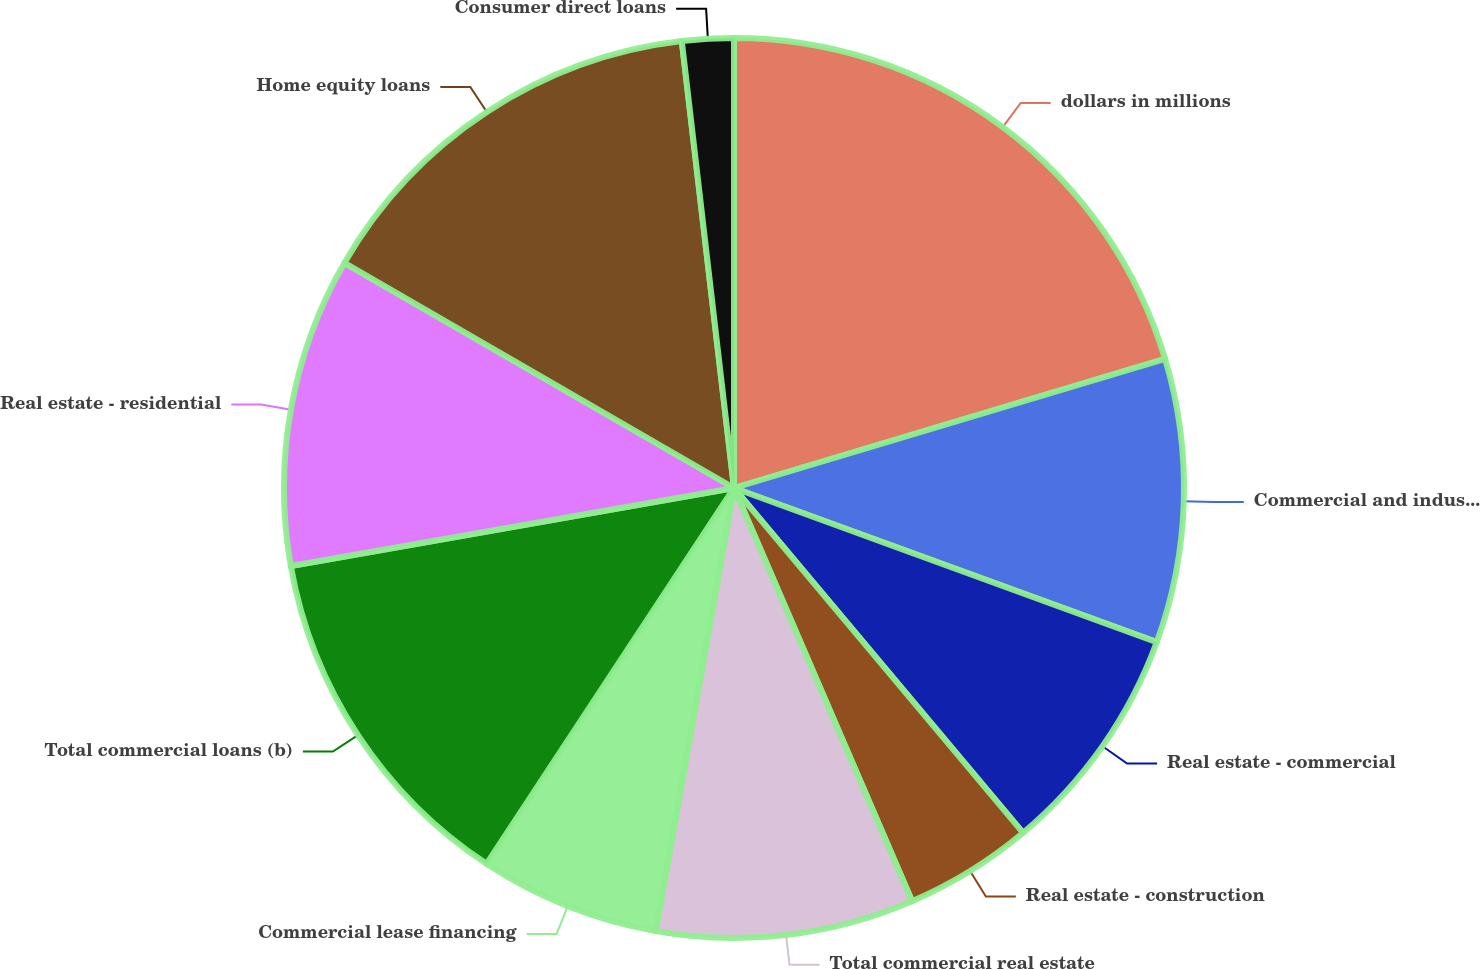<chart> <loc_0><loc_0><loc_500><loc_500><pie_chart><fcel>dollars in millions<fcel>Commercial and industrial<fcel>Real estate - commercial<fcel>Real estate - construction<fcel>Total commercial real estate<fcel>Commercial lease financing<fcel>Total commercial loans (b)<fcel>Real estate - residential<fcel>Home equity loans<fcel>Consumer direct loans<nl><fcel>20.37%<fcel>10.19%<fcel>8.33%<fcel>4.63%<fcel>9.26%<fcel>6.48%<fcel>12.96%<fcel>11.11%<fcel>14.81%<fcel>1.85%<nl></chart> 